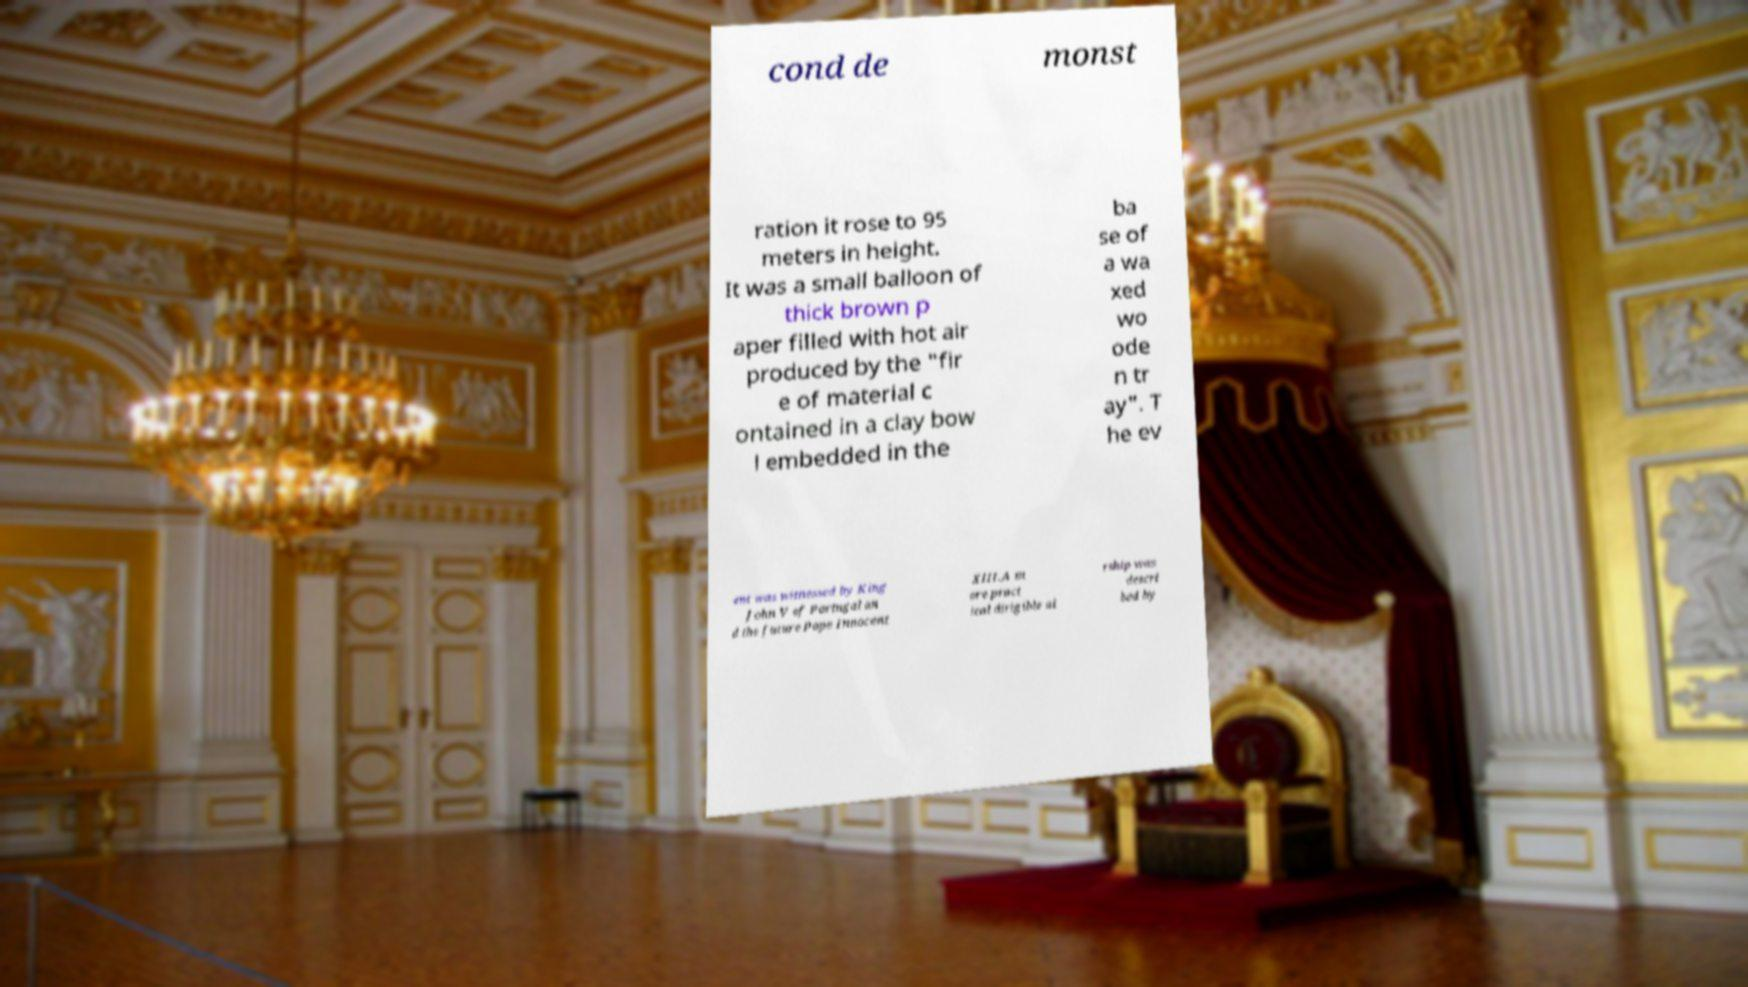For documentation purposes, I need the text within this image transcribed. Could you provide that? cond de monst ration it rose to 95 meters in height. It was a small balloon of thick brown p aper filled with hot air produced by the "fir e of material c ontained in a clay bow l embedded in the ba se of a wa xed wo ode n tr ay". T he ev ent was witnessed by King John V of Portugal an d the future Pope Innocent XIII.A m ore pract ical dirigible ai rship was descri bed by 